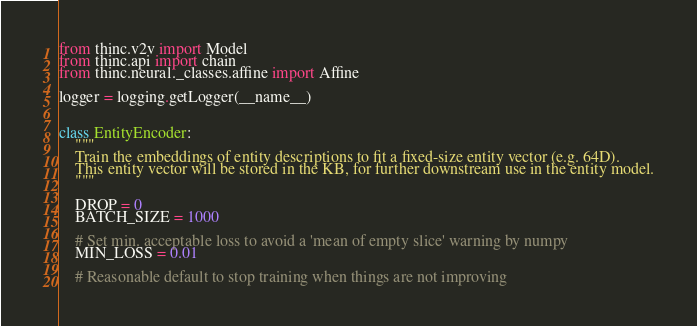<code> <loc_0><loc_0><loc_500><loc_500><_Python_>
from thinc.v2v import Model
from thinc.api import chain
from thinc.neural._classes.affine import Affine

logger = logging.getLogger(__name__)


class EntityEncoder:
    """
    Train the embeddings of entity descriptions to fit a fixed-size entity vector (e.g. 64D).
    This entity vector will be stored in the KB, for further downstream use in the entity model.
    """

    DROP = 0
    BATCH_SIZE = 1000

    # Set min. acceptable loss to avoid a 'mean of empty slice' warning by numpy
    MIN_LOSS = 0.01

    # Reasonable default to stop training when things are not improving</code> 